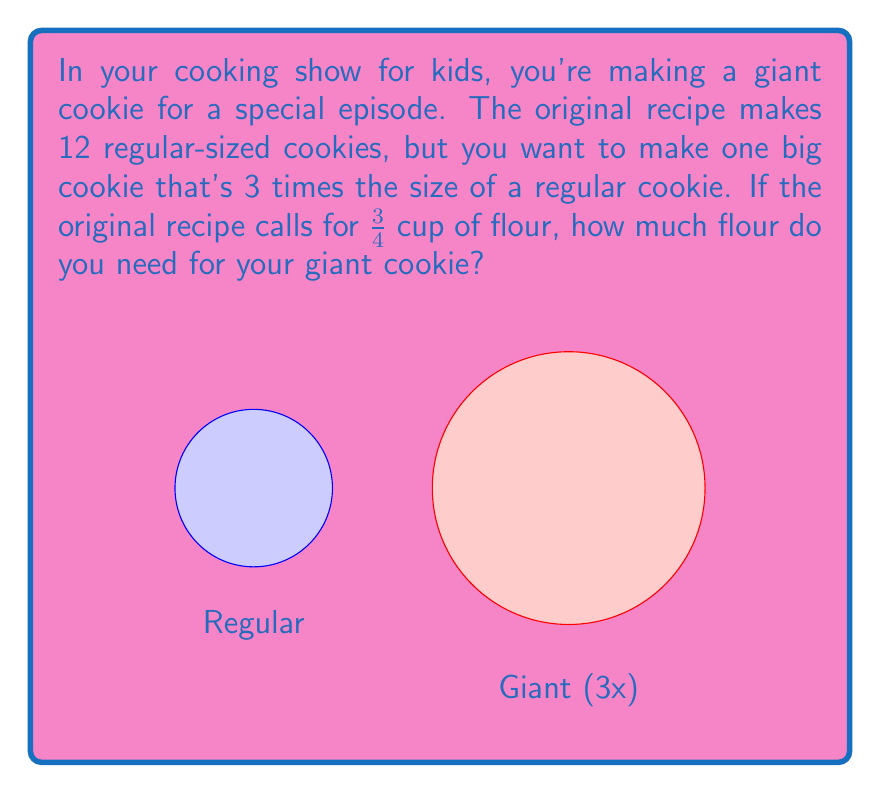Can you solve this math problem? Let's approach this step-by-step:

1) First, we need to understand what the question is asking:
   - The original recipe makes 12 regular cookies
   - We want to make 1 giant cookie that's 3 times the size of a regular cookie
   - The original recipe uses $\frac{3}{4}$ cup of flour

2) Since our giant cookie is 3 times the size of a regular cookie, we might think we need 3 times the flour. However, we're only making one cookie instead of 12.

3) To find out how much flour we need, we can:
   a) Calculate how much flour is used for one regular cookie
   b) Multiply that by 3 for our giant cookie

4) Let's calculate the flour for one regular cookie:
   - Original recipe (12 cookies): $\frac{3}{4}$ cup
   - For 1 cookie: $\frac{3}{4} \div 12 = \frac{3}{48} = \frac{1}{16}$ cup

5) Now, for our giant cookie (3 times the size):
   $\frac{1}{16} \times 3 = \frac{3}{16}$ cup

Therefore, we need $\frac{3}{16}$ cup of flour for our giant cookie.
Answer: $\frac{3}{16}$ cup 